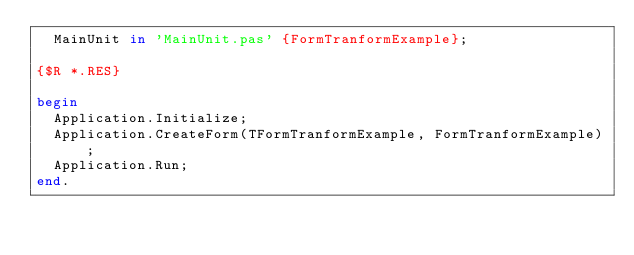<code> <loc_0><loc_0><loc_500><loc_500><_Pascal_>  MainUnit in 'MainUnit.pas' {FormTranformExample};

{$R *.RES}

begin
  Application.Initialize;
  Application.CreateForm(TFormTranformExample, FormTranformExample);
  Application.Run;
end.
</code> 